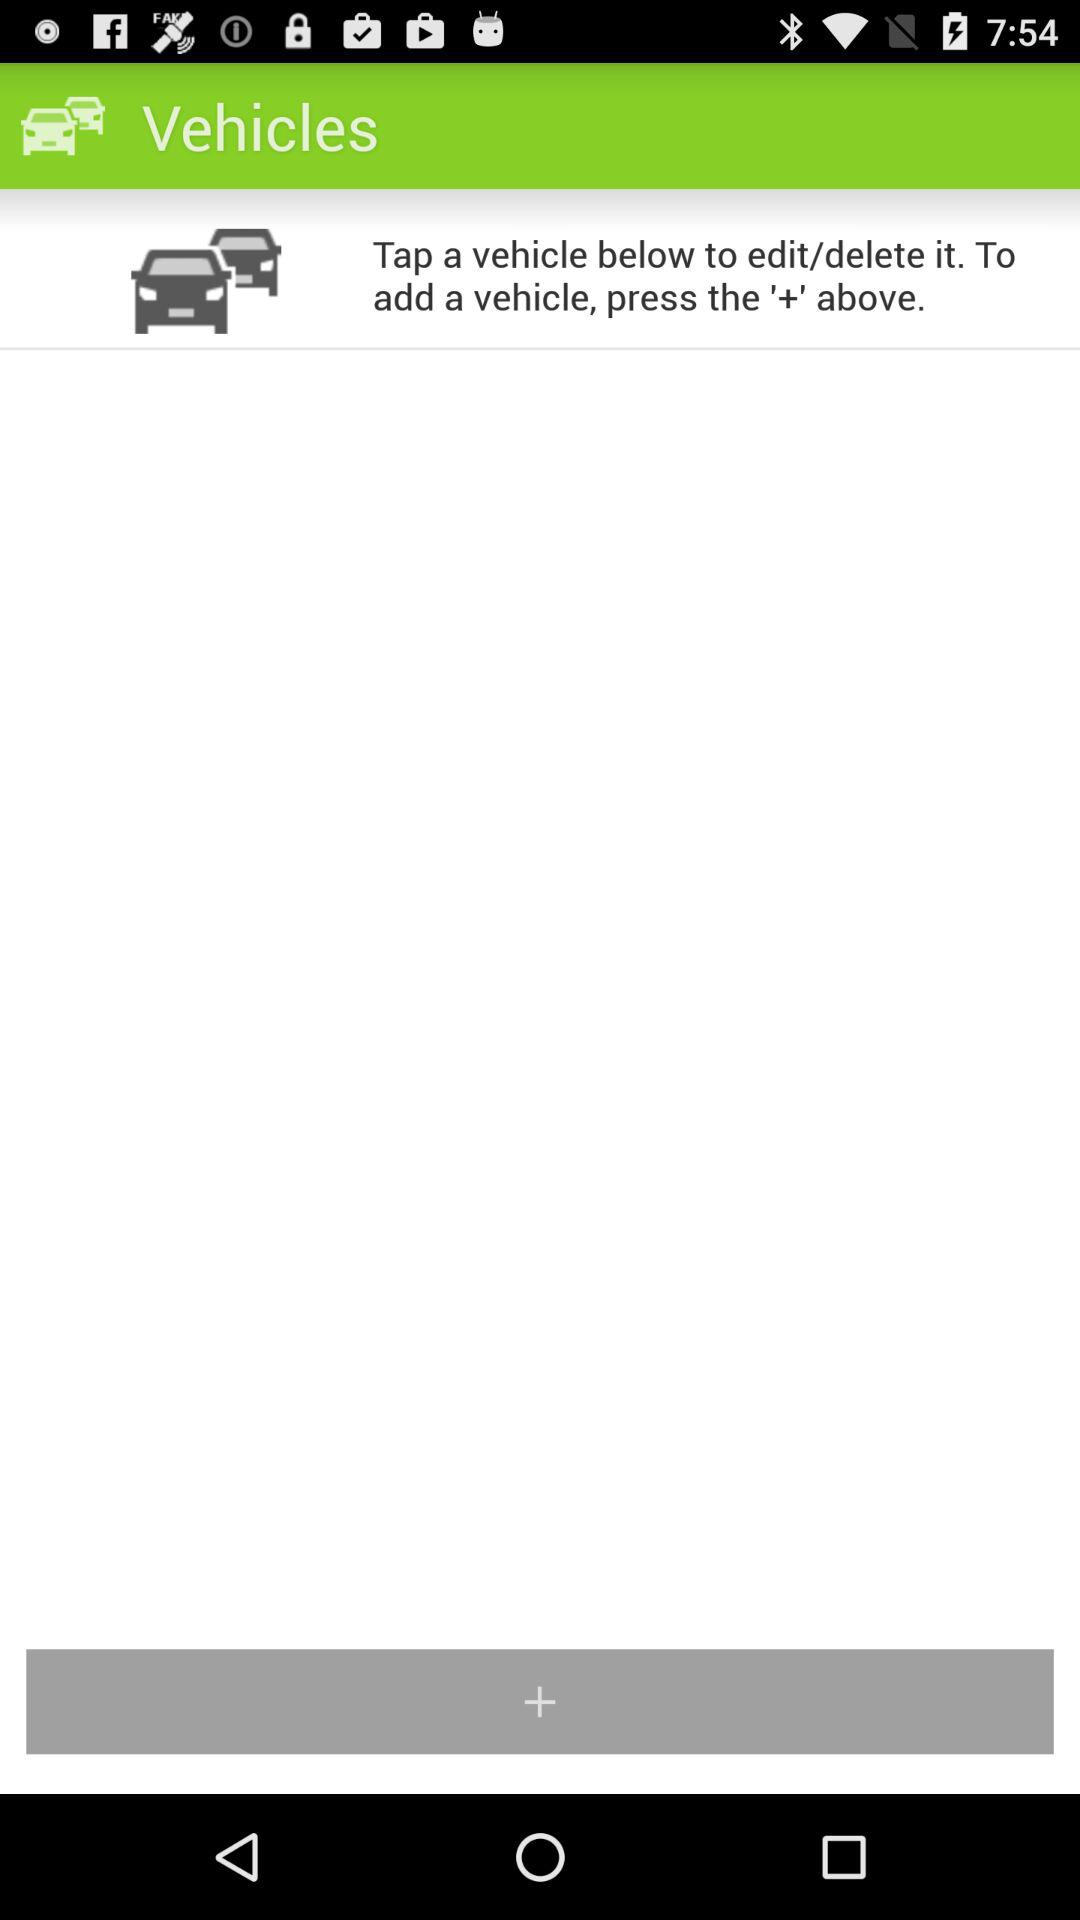What button has to be pressed to add a vehicle? "To add a vehicle, press the '+' above.". 